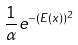<formula> <loc_0><loc_0><loc_500><loc_500>\frac { 1 } { \alpha } e ^ { - ( E ( x ) ) ^ { 2 } }</formula> 